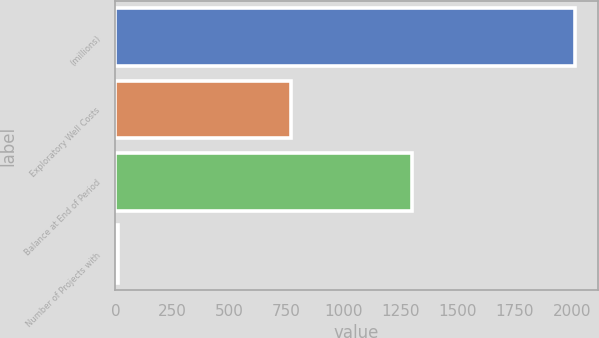<chart> <loc_0><loc_0><loc_500><loc_500><bar_chart><fcel>(millions)<fcel>Exploratory Well Costs<fcel>Balance at End of Period<fcel>Number of Projects with<nl><fcel>2013<fcel>768<fcel>1301<fcel>13<nl></chart> 